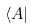<formula> <loc_0><loc_0><loc_500><loc_500>\langle A |</formula> 